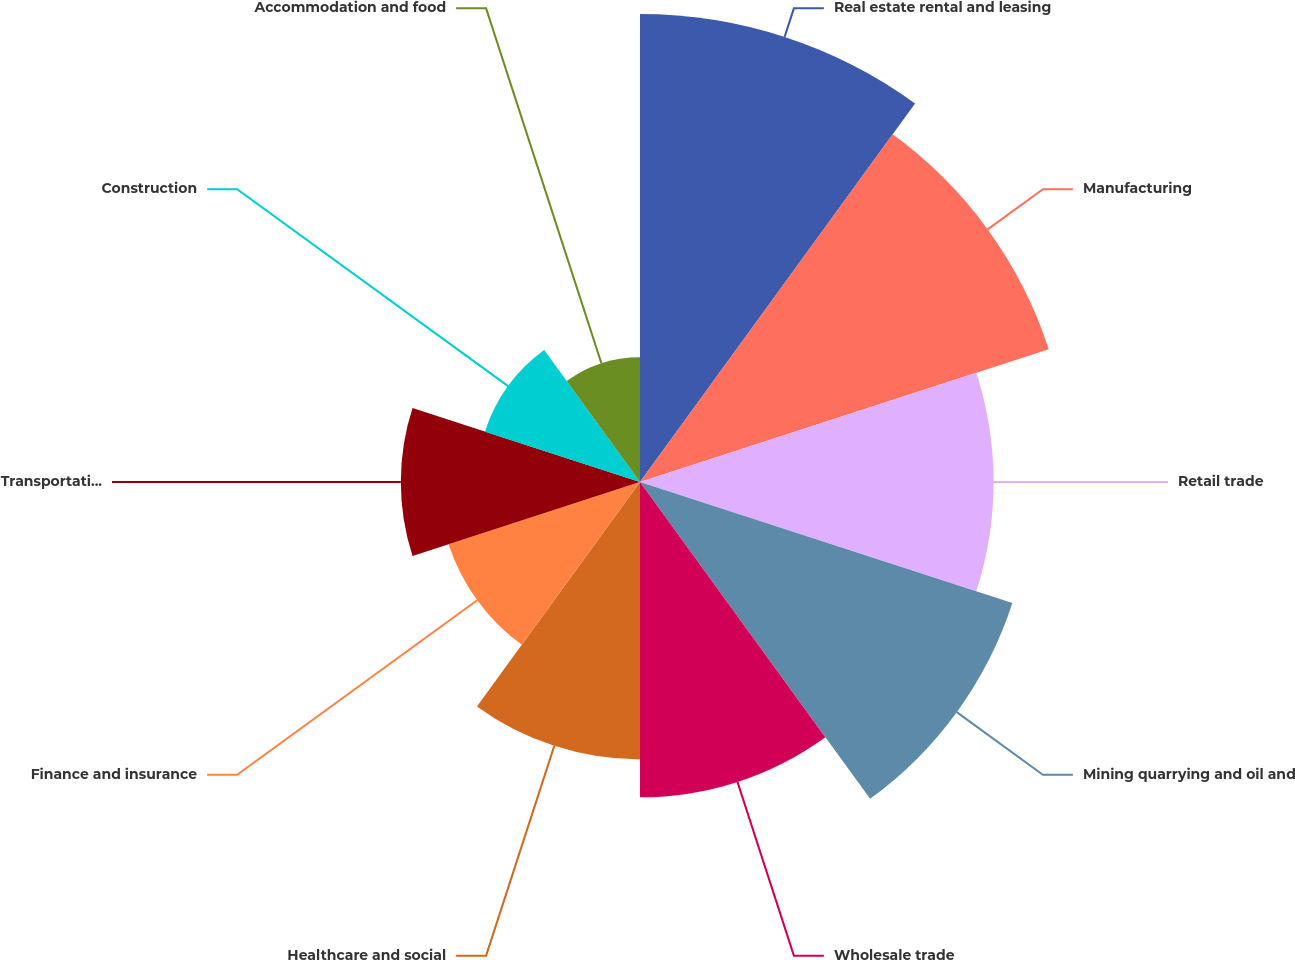Convert chart. <chart><loc_0><loc_0><loc_500><loc_500><pie_chart><fcel>Real estate rental and leasing<fcel>Manufacturing<fcel>Retail trade<fcel>Mining quarrying and oil and<fcel>Wholesale trade<fcel>Healthcare and social<fcel>Finance and insurance<fcel>Transportation and warehousing<fcel>Construction<fcel>Accommodation and food<nl><fcel>15.79%<fcel>14.5%<fcel>11.93%<fcel>13.21%<fcel>10.64%<fcel>9.36%<fcel>6.79%<fcel>8.07%<fcel>5.5%<fcel>4.21%<nl></chart> 